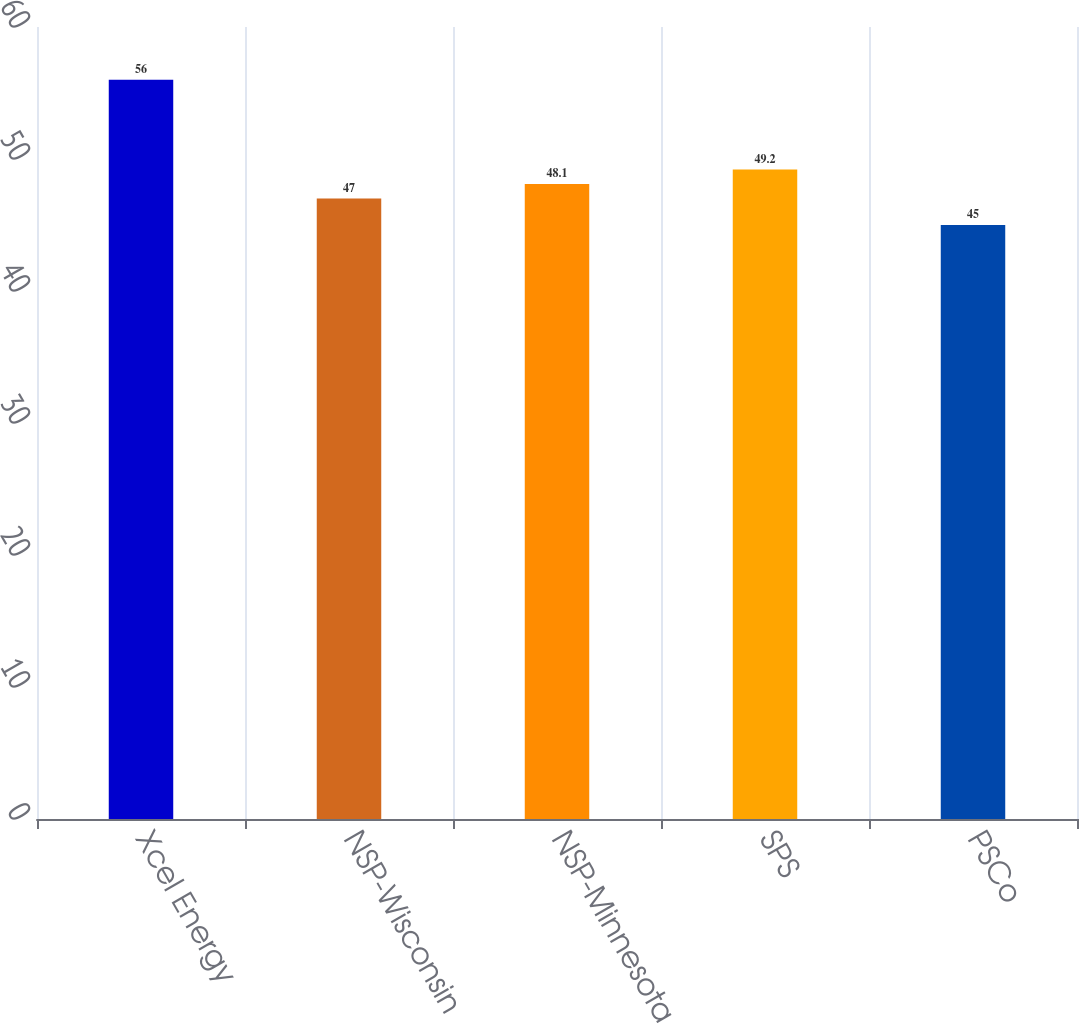<chart> <loc_0><loc_0><loc_500><loc_500><bar_chart><fcel>Xcel Energy<fcel>NSP-Wisconsin<fcel>NSP-Minnesota<fcel>SPS<fcel>PSCo<nl><fcel>56<fcel>47<fcel>48.1<fcel>49.2<fcel>45<nl></chart> 